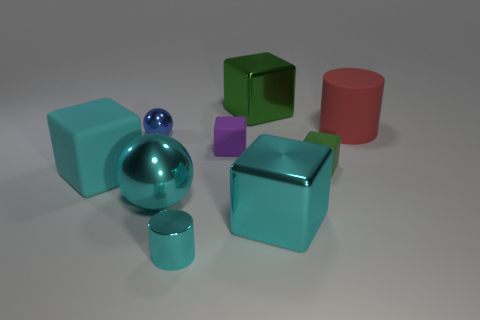Is the color of the large sphere the same as the metal cylinder?
Make the answer very short. Yes. The matte cylinder has what size?
Keep it short and to the point. Large. There is a cylinder that is the same color as the big shiny ball; what is its material?
Your response must be concise. Metal. What number of large blocks have the same color as the large shiny sphere?
Provide a short and direct response. 2. Does the blue metal object have the same size as the red cylinder?
Offer a very short reply. No. What size is the cylinder in front of the metallic ball behind the green matte thing?
Your answer should be compact. Small. There is a large ball; does it have the same color as the rubber thing on the left side of the large cyan shiny sphere?
Ensure brevity in your answer.  Yes. Are there any green rubber things of the same size as the purple cube?
Make the answer very short. Yes. There is a cyan metallic thing that is on the right side of the green shiny cube; how big is it?
Your answer should be compact. Large. There is a object behind the red matte cylinder; are there any large shiny blocks that are on the right side of it?
Offer a terse response. Yes. 